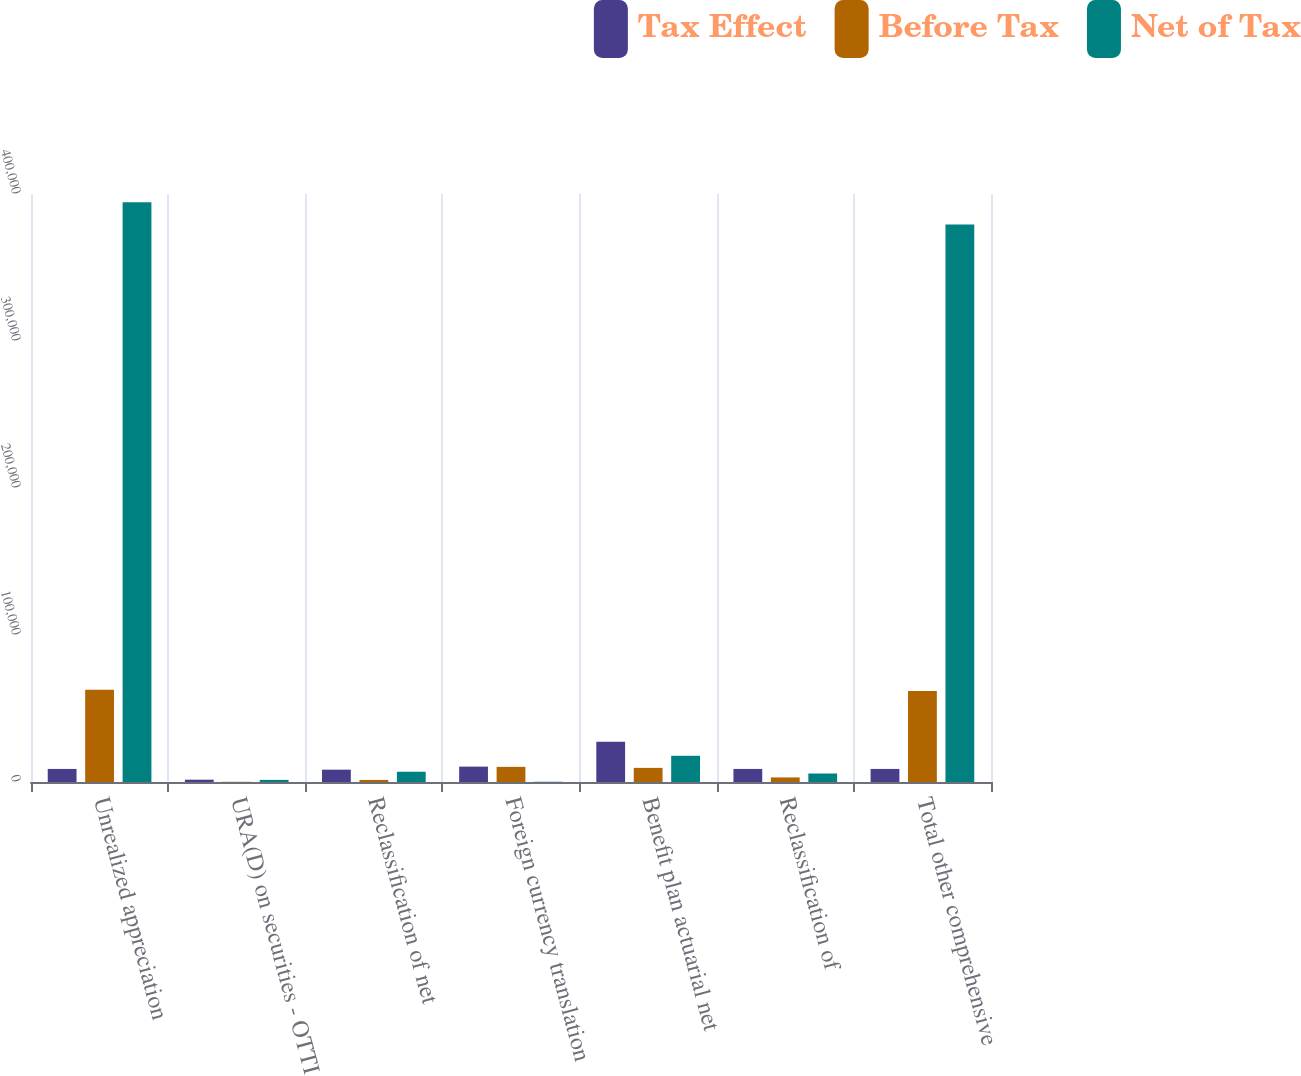<chart> <loc_0><loc_0><loc_500><loc_500><stacked_bar_chart><ecel><fcel>Unrealized appreciation<fcel>URA(D) on securities - OTTI<fcel>Reclassification of net<fcel>Foreign currency translation<fcel>Benefit plan actuarial net<fcel>Reclassification of<fcel>Total other comprehensive<nl><fcel>Tax Effect<fcel>8889<fcel>1579<fcel>8388<fcel>10462<fcel>27442<fcel>8889<fcel>8889<nl><fcel>Before Tax<fcel>62834<fcel>140<fcel>1411<fcel>10300<fcel>9605<fcel>3111<fcel>61969<nl><fcel>Net of Tax<fcel>394358<fcel>1439<fcel>6977<fcel>162<fcel>17837<fcel>5778<fcel>379321<nl></chart> 